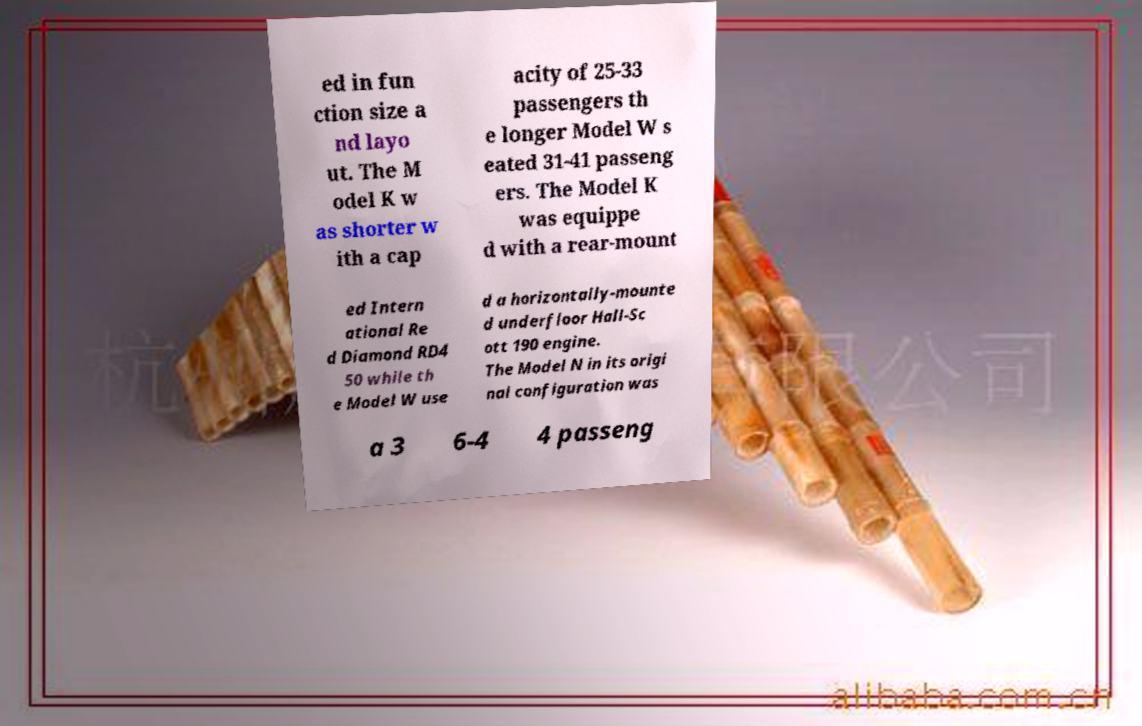I need the written content from this picture converted into text. Can you do that? ed in fun ction size a nd layo ut. The M odel K w as shorter w ith a cap acity of 25-33 passengers th e longer Model W s eated 31-41 passeng ers. The Model K was equippe d with a rear-mount ed Intern ational Re d Diamond RD4 50 while th e Model W use d a horizontally-mounte d underfloor Hall-Sc ott 190 engine. The Model N in its origi nal configuration was a 3 6-4 4 passeng 